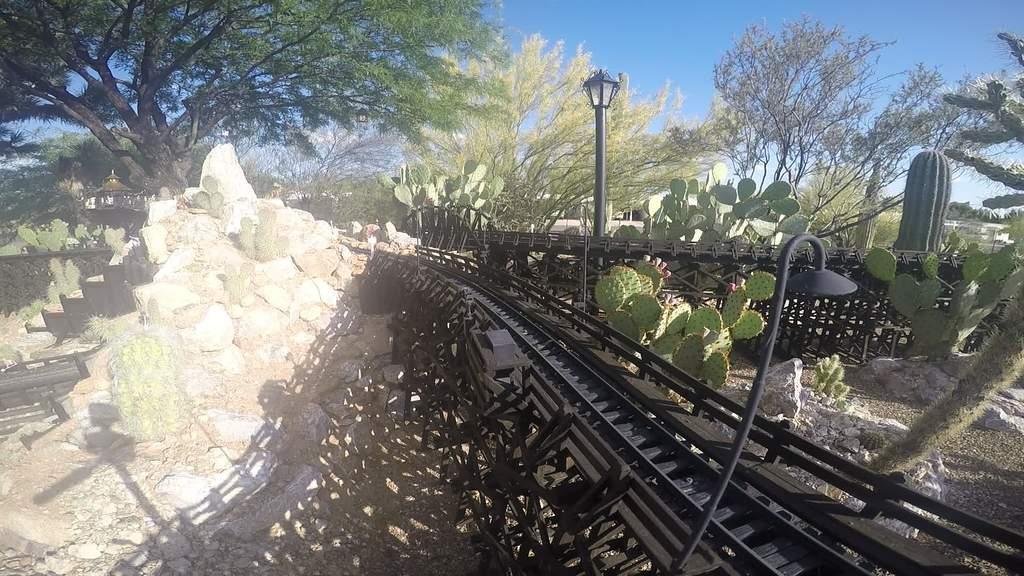Can you describe this image briefly? In this image at the bottom there is some track, and in the center also there is a track might be a railway track. And on the right side and left side there are some plants, sand, rocks and on the left side there is a staircase. In the background there are some houses, trees and wall, light. At the top of the image there is sky, and in the foreground there is one light. 